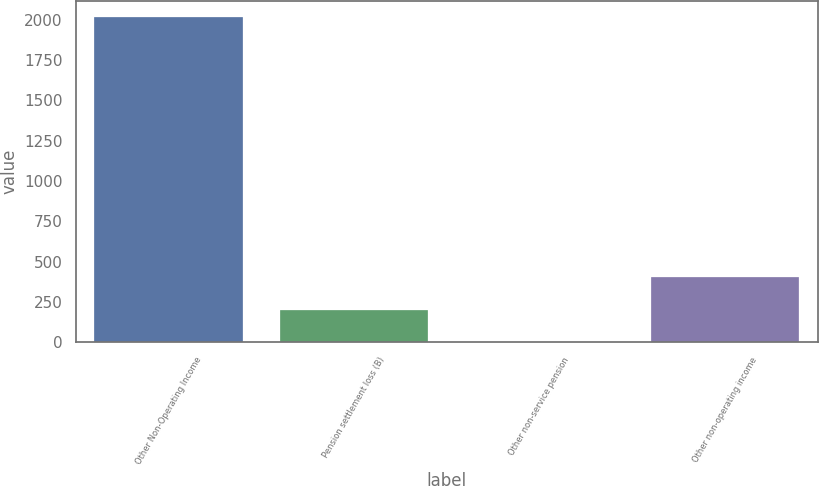<chart> <loc_0><loc_0><loc_500><loc_500><bar_chart><fcel>Other Non-Operating Income<fcel>Pension settlement loss (B)<fcel>Other non-service pension<fcel>Other non-operating income<nl><fcel>2017<fcel>203.41<fcel>1.9<fcel>404.92<nl></chart> 